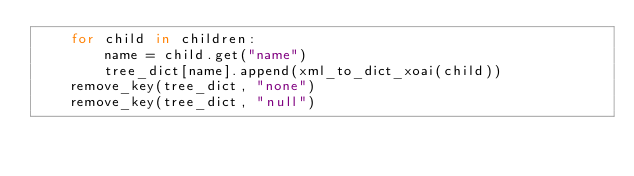Convert code to text. <code><loc_0><loc_0><loc_500><loc_500><_Python_>    for child in children:
        name = child.get("name")
        tree_dict[name].append(xml_to_dict_xoai(child))
    remove_key(tree_dict, "none")
    remove_key(tree_dict, "null")</code> 